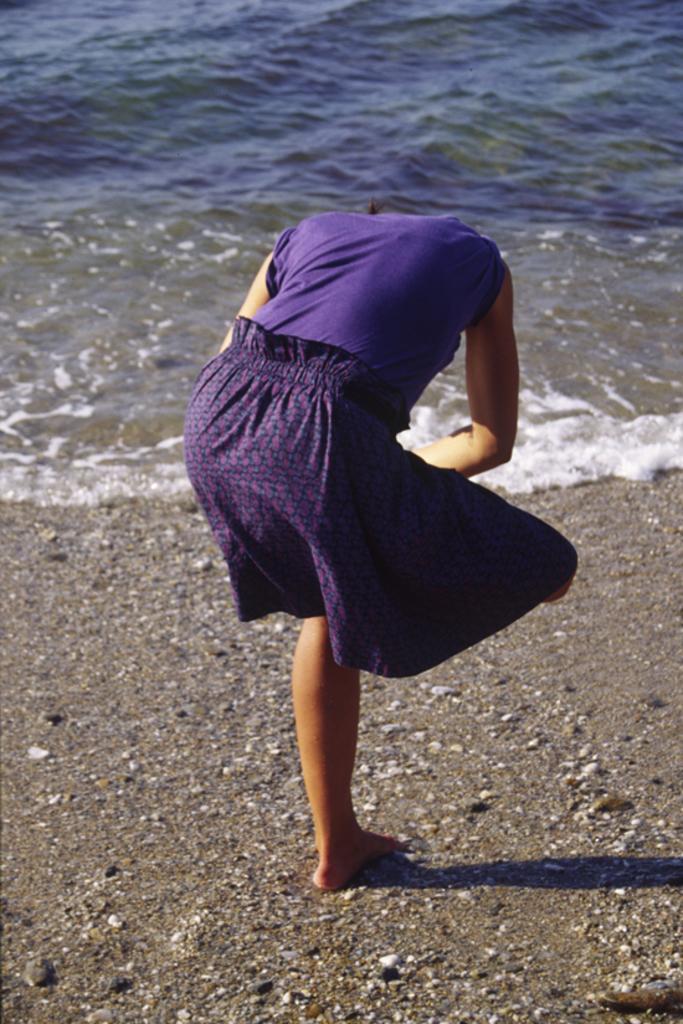How would you summarize this image in a sentence or two? In this picture I can see a woman standing on the land side of the water. 